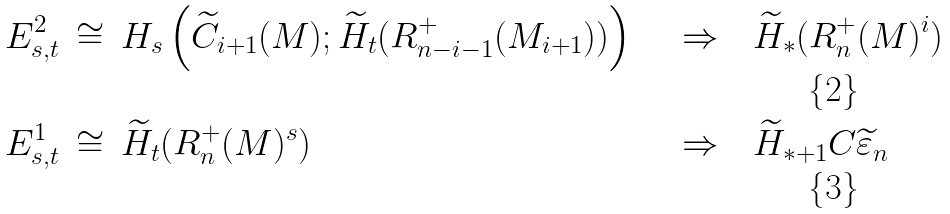Convert formula to latex. <formula><loc_0><loc_0><loc_500><loc_500>E _ { s , t } ^ { 2 } \, & \cong \, H _ { s } \left ( \widetilde { C } _ { i + 1 } ( M ) ; \widetilde { H } _ { t } ( R _ { n - i - 1 } ^ { + } ( M _ { i + 1 } ) ) \right ) \quad & \Rightarrow \quad & \widetilde { H } _ { * } ( R _ { n } ^ { + } ( M ) ^ { i } ) \\ E _ { s , t } ^ { 1 } \, & \cong \, \widetilde { H } _ { t } ( R _ { n } ^ { + } ( M ) ^ { s } ) \quad & \Rightarrow \quad & \widetilde { H } _ { * + 1 } C \widetilde { \varepsilon } _ { n }</formula> 